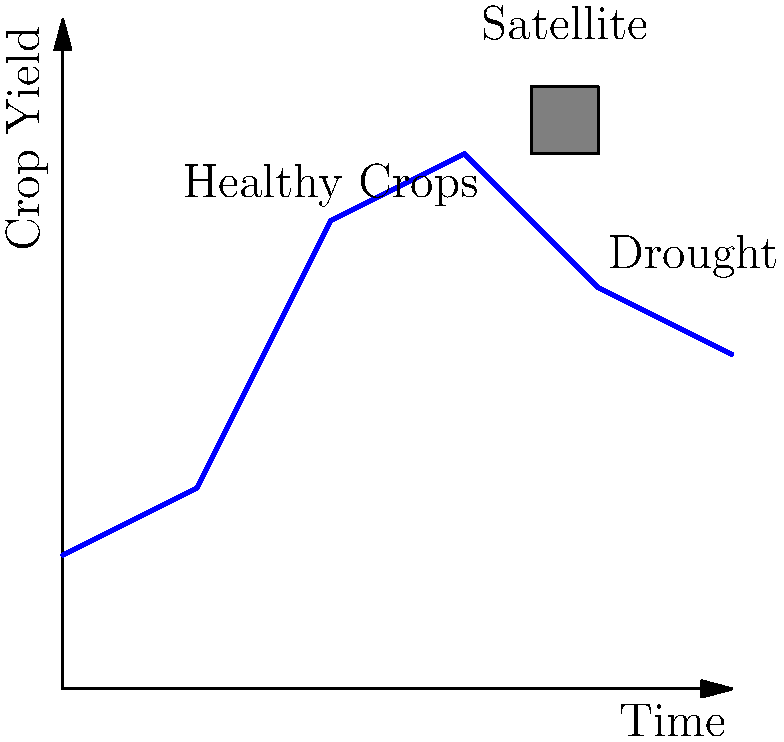In your work with Father Erwin Hain in Cameroon, you've been tasked with estimating crop yields using satellite imagery. The graph shows crop yield over time, with a sudden decrease towards the end. What machine learning technique would be most appropriate for predicting future crop yields based on this data, and how might it help local farmers in your parish? To answer this question, let's consider the following steps:

1. Analyze the data: The graph shows a time series of crop yields, with variations over time and a sudden decrease towards the end.

2. Identify the problem type: This is a time series prediction problem, where we need to forecast future crop yields based on historical data.

3. Consider the most appropriate machine learning techniques:
   a) Time Series Forecasting models (e.g., ARIMA, Prophet)
   b) Recurrent Neural Networks (RNNs), especially Long Short-Term Memory (LSTM) networks
   c) Random Forests or Gradient Boosting Machines for regression

4. Select the best technique: Given the complex patterns and potential external factors (like drought), an LSTM network would be most appropriate. LSTMs can capture long-term dependencies and are well-suited for time series data with irregular patterns.

5. Application to local farmers:
   a) Early warning system: Predict potential crop failures or low yields in advance
   b) Resource allocation: Help farmers plan for irrigation, fertilizer use, and harvesting
   c) Crop selection: Assist in choosing crops that are likely to perform well given the predicted conditions
   d) Financial planning: Aid in estimating income and managing finances based on yield predictions

6. Integration with Catholic mission: As a priest working with Father Erwin Hain, this technology can be used to support the local community, aligning with the Church's mission of social justice and caring for the poor by helping ensure food security and sustainable livelihoods.
Answer: LSTM network for time series prediction, helping farmers with early warnings, resource allocation, crop selection, and financial planning. 